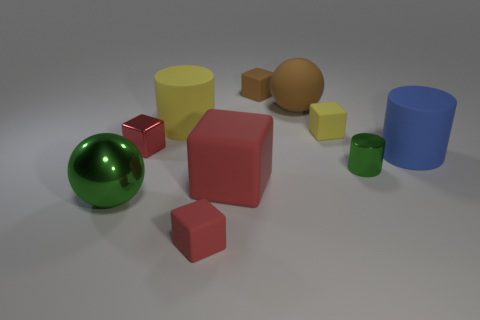What color is the other small metal object that is the same shape as the blue object?
Provide a succinct answer. Green. Are there any other things that have the same color as the tiny metallic block?
Make the answer very short. Yes. How many other objects are the same material as the large blue cylinder?
Make the answer very short. 6. The yellow cube is what size?
Make the answer very short. Small. Is there a tiny shiny thing of the same shape as the big red rubber thing?
Provide a succinct answer. Yes. What number of things are red shiny things or cylinders that are behind the small metallic cylinder?
Keep it short and to the point. 3. The small shiny object that is to the left of the small yellow object is what color?
Offer a terse response. Red. Do the rubber block in front of the large metal ball and the cube that is behind the large yellow object have the same size?
Offer a very short reply. Yes. Are there any red spheres that have the same size as the red shiny block?
Your answer should be compact. No. What number of small matte blocks are in front of the small metallic object that is on the left side of the large matte cube?
Provide a short and direct response. 1. 